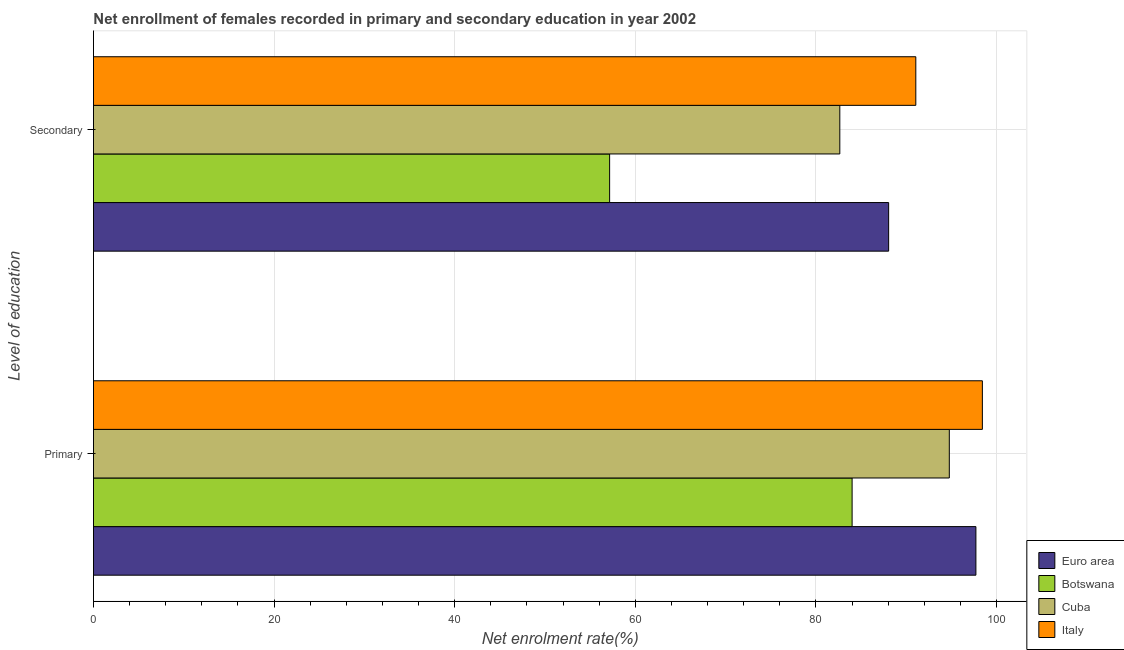How many different coloured bars are there?
Give a very brief answer. 4. How many groups of bars are there?
Make the answer very short. 2. Are the number of bars per tick equal to the number of legend labels?
Provide a short and direct response. Yes. How many bars are there on the 1st tick from the bottom?
Your answer should be very brief. 4. What is the label of the 1st group of bars from the top?
Make the answer very short. Secondary. What is the enrollment rate in secondary education in Botswana?
Offer a terse response. 57.16. Across all countries, what is the maximum enrollment rate in primary education?
Your answer should be very brief. 98.44. Across all countries, what is the minimum enrollment rate in secondary education?
Ensure brevity in your answer.  57.16. In which country was the enrollment rate in secondary education minimum?
Provide a short and direct response. Botswana. What is the total enrollment rate in primary education in the graph?
Ensure brevity in your answer.  374.95. What is the difference between the enrollment rate in secondary education in Cuba and that in Botswana?
Ensure brevity in your answer.  25.49. What is the difference between the enrollment rate in secondary education in Cuba and the enrollment rate in primary education in Botswana?
Offer a terse response. -1.36. What is the average enrollment rate in secondary education per country?
Make the answer very short. 79.73. What is the difference between the enrollment rate in secondary education and enrollment rate in primary education in Italy?
Your answer should be very brief. -7.37. What is the ratio of the enrollment rate in secondary education in Italy to that in Cuba?
Make the answer very short. 1.1. In how many countries, is the enrollment rate in secondary education greater than the average enrollment rate in secondary education taken over all countries?
Provide a short and direct response. 3. What does the 1st bar from the top in Primary represents?
Your answer should be compact. Italy. What does the 4th bar from the bottom in Primary represents?
Offer a terse response. Italy. How many bars are there?
Give a very brief answer. 8. How many countries are there in the graph?
Make the answer very short. 4. Does the graph contain any zero values?
Provide a short and direct response. No. How many legend labels are there?
Provide a succinct answer. 4. How are the legend labels stacked?
Ensure brevity in your answer.  Vertical. What is the title of the graph?
Offer a terse response. Net enrollment of females recorded in primary and secondary education in year 2002. What is the label or title of the X-axis?
Give a very brief answer. Net enrolment rate(%). What is the label or title of the Y-axis?
Make the answer very short. Level of education. What is the Net enrolment rate(%) in Euro area in Primary?
Provide a succinct answer. 97.72. What is the Net enrolment rate(%) in Botswana in Primary?
Provide a succinct answer. 84.01. What is the Net enrolment rate(%) in Cuba in Primary?
Offer a very short reply. 94.78. What is the Net enrolment rate(%) of Italy in Primary?
Give a very brief answer. 98.44. What is the Net enrolment rate(%) of Euro area in Secondary?
Make the answer very short. 88.06. What is the Net enrolment rate(%) in Botswana in Secondary?
Keep it short and to the point. 57.16. What is the Net enrolment rate(%) in Cuba in Secondary?
Your answer should be compact. 82.65. What is the Net enrolment rate(%) in Italy in Secondary?
Offer a very short reply. 91.07. Across all Level of education, what is the maximum Net enrolment rate(%) in Euro area?
Your answer should be very brief. 97.72. Across all Level of education, what is the maximum Net enrolment rate(%) in Botswana?
Offer a very short reply. 84.01. Across all Level of education, what is the maximum Net enrolment rate(%) of Cuba?
Ensure brevity in your answer.  94.78. Across all Level of education, what is the maximum Net enrolment rate(%) in Italy?
Your answer should be very brief. 98.44. Across all Level of education, what is the minimum Net enrolment rate(%) in Euro area?
Offer a terse response. 88.06. Across all Level of education, what is the minimum Net enrolment rate(%) in Botswana?
Offer a terse response. 57.16. Across all Level of education, what is the minimum Net enrolment rate(%) of Cuba?
Offer a terse response. 82.65. Across all Level of education, what is the minimum Net enrolment rate(%) in Italy?
Your answer should be very brief. 91.07. What is the total Net enrolment rate(%) of Euro area in the graph?
Provide a succinct answer. 185.78. What is the total Net enrolment rate(%) of Botswana in the graph?
Your response must be concise. 141.17. What is the total Net enrolment rate(%) of Cuba in the graph?
Offer a very short reply. 177.43. What is the total Net enrolment rate(%) of Italy in the graph?
Ensure brevity in your answer.  189.51. What is the difference between the Net enrolment rate(%) of Euro area in Primary and that in Secondary?
Your answer should be compact. 9.66. What is the difference between the Net enrolment rate(%) in Botswana in Primary and that in Secondary?
Offer a very short reply. 26.85. What is the difference between the Net enrolment rate(%) in Cuba in Primary and that in Secondary?
Ensure brevity in your answer.  12.12. What is the difference between the Net enrolment rate(%) of Italy in Primary and that in Secondary?
Your answer should be compact. 7.37. What is the difference between the Net enrolment rate(%) of Euro area in Primary and the Net enrolment rate(%) of Botswana in Secondary?
Keep it short and to the point. 40.56. What is the difference between the Net enrolment rate(%) of Euro area in Primary and the Net enrolment rate(%) of Cuba in Secondary?
Your answer should be very brief. 15.07. What is the difference between the Net enrolment rate(%) in Euro area in Primary and the Net enrolment rate(%) in Italy in Secondary?
Offer a terse response. 6.65. What is the difference between the Net enrolment rate(%) of Botswana in Primary and the Net enrolment rate(%) of Cuba in Secondary?
Keep it short and to the point. 1.36. What is the difference between the Net enrolment rate(%) of Botswana in Primary and the Net enrolment rate(%) of Italy in Secondary?
Offer a very short reply. -7.05. What is the difference between the Net enrolment rate(%) in Cuba in Primary and the Net enrolment rate(%) in Italy in Secondary?
Your response must be concise. 3.71. What is the average Net enrolment rate(%) of Euro area per Level of education?
Ensure brevity in your answer.  92.89. What is the average Net enrolment rate(%) in Botswana per Level of education?
Provide a succinct answer. 70.59. What is the average Net enrolment rate(%) of Cuba per Level of education?
Offer a very short reply. 88.71. What is the average Net enrolment rate(%) in Italy per Level of education?
Offer a very short reply. 94.75. What is the difference between the Net enrolment rate(%) in Euro area and Net enrolment rate(%) in Botswana in Primary?
Your answer should be very brief. 13.71. What is the difference between the Net enrolment rate(%) in Euro area and Net enrolment rate(%) in Cuba in Primary?
Offer a terse response. 2.95. What is the difference between the Net enrolment rate(%) in Euro area and Net enrolment rate(%) in Italy in Primary?
Ensure brevity in your answer.  -0.72. What is the difference between the Net enrolment rate(%) of Botswana and Net enrolment rate(%) of Cuba in Primary?
Provide a short and direct response. -10.76. What is the difference between the Net enrolment rate(%) of Botswana and Net enrolment rate(%) of Italy in Primary?
Your answer should be very brief. -14.43. What is the difference between the Net enrolment rate(%) of Cuba and Net enrolment rate(%) of Italy in Primary?
Ensure brevity in your answer.  -3.66. What is the difference between the Net enrolment rate(%) in Euro area and Net enrolment rate(%) in Botswana in Secondary?
Your answer should be compact. 30.9. What is the difference between the Net enrolment rate(%) in Euro area and Net enrolment rate(%) in Cuba in Secondary?
Offer a terse response. 5.41. What is the difference between the Net enrolment rate(%) in Euro area and Net enrolment rate(%) in Italy in Secondary?
Ensure brevity in your answer.  -3.01. What is the difference between the Net enrolment rate(%) of Botswana and Net enrolment rate(%) of Cuba in Secondary?
Make the answer very short. -25.49. What is the difference between the Net enrolment rate(%) in Botswana and Net enrolment rate(%) in Italy in Secondary?
Your response must be concise. -33.91. What is the difference between the Net enrolment rate(%) in Cuba and Net enrolment rate(%) in Italy in Secondary?
Provide a succinct answer. -8.42. What is the ratio of the Net enrolment rate(%) in Euro area in Primary to that in Secondary?
Give a very brief answer. 1.11. What is the ratio of the Net enrolment rate(%) of Botswana in Primary to that in Secondary?
Offer a very short reply. 1.47. What is the ratio of the Net enrolment rate(%) in Cuba in Primary to that in Secondary?
Give a very brief answer. 1.15. What is the ratio of the Net enrolment rate(%) in Italy in Primary to that in Secondary?
Your answer should be compact. 1.08. What is the difference between the highest and the second highest Net enrolment rate(%) in Euro area?
Provide a short and direct response. 9.66. What is the difference between the highest and the second highest Net enrolment rate(%) of Botswana?
Ensure brevity in your answer.  26.85. What is the difference between the highest and the second highest Net enrolment rate(%) in Cuba?
Give a very brief answer. 12.12. What is the difference between the highest and the second highest Net enrolment rate(%) of Italy?
Offer a very short reply. 7.37. What is the difference between the highest and the lowest Net enrolment rate(%) in Euro area?
Your answer should be compact. 9.66. What is the difference between the highest and the lowest Net enrolment rate(%) in Botswana?
Offer a terse response. 26.85. What is the difference between the highest and the lowest Net enrolment rate(%) in Cuba?
Make the answer very short. 12.12. What is the difference between the highest and the lowest Net enrolment rate(%) in Italy?
Ensure brevity in your answer.  7.37. 